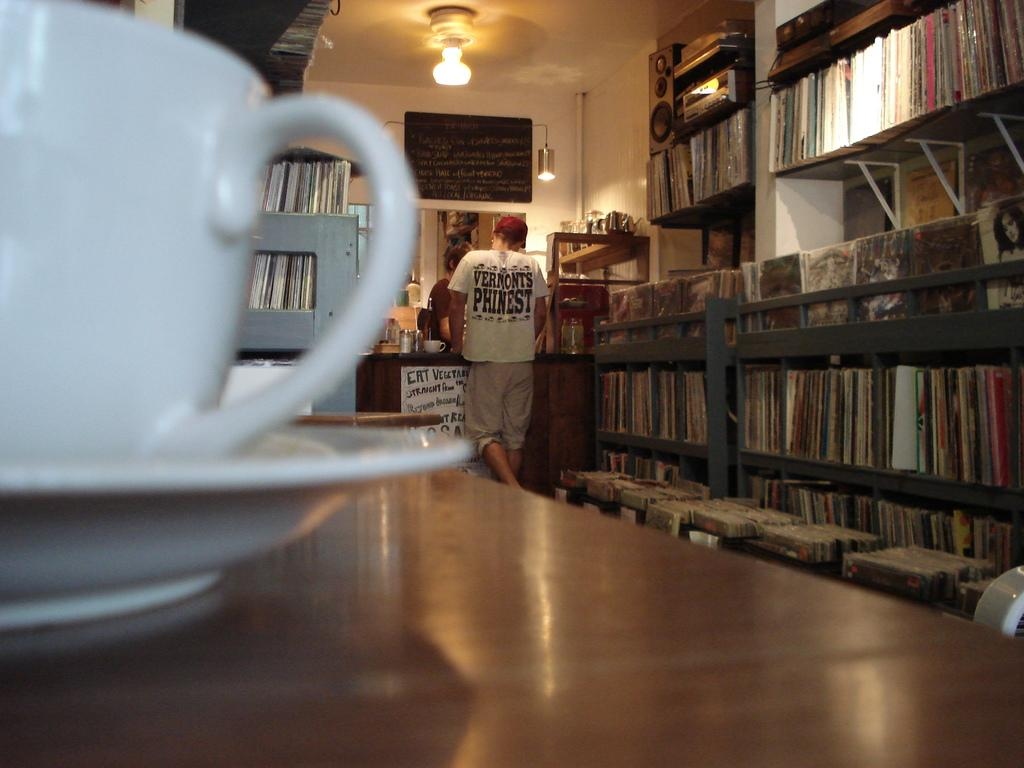<image>
Provide a brief description of the given image. A sign on the counter advises people to eat vegetarian. 